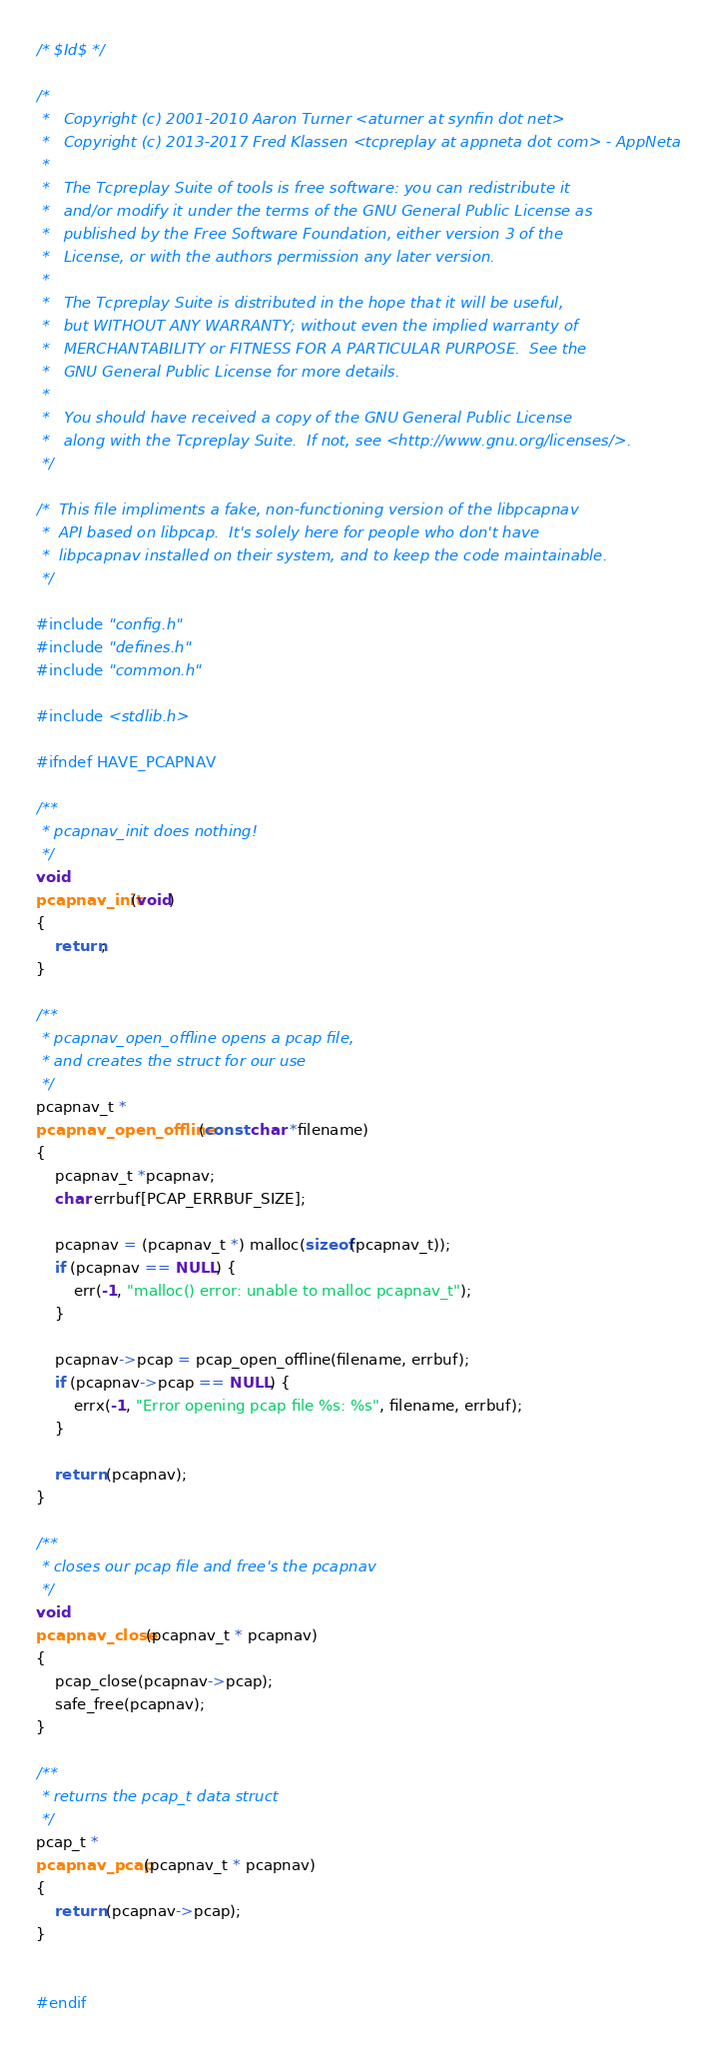<code> <loc_0><loc_0><loc_500><loc_500><_C_>/* $Id$ */

/*
 *   Copyright (c) 2001-2010 Aaron Turner <aturner at synfin dot net>
 *   Copyright (c) 2013-2017 Fred Klassen <tcpreplay at appneta dot com> - AppNeta
 *
 *   The Tcpreplay Suite of tools is free software: you can redistribute it 
 *   and/or modify it under the terms of the GNU General Public License as 
 *   published by the Free Software Foundation, either version 3 of the 
 *   License, or with the authors permission any later version.
 *
 *   The Tcpreplay Suite is distributed in the hope that it will be useful,
 *   but WITHOUT ANY WARRANTY; without even the implied warranty of
 *   MERCHANTABILITY or FITNESS FOR A PARTICULAR PURPOSE.  See the
 *   GNU General Public License for more details.
 *
 *   You should have received a copy of the GNU General Public License
 *   along with the Tcpreplay Suite.  If not, see <http://www.gnu.org/licenses/>.
 */

/*  This file impliments a fake, non-functioning version of the libpcapnav
 *  API based on libpcap.  It's solely here for people who don't have 
 *  libpcapnav installed on their system, and to keep the code maintainable.
 */

#include "config.h"
#include "defines.h"
#include "common.h"

#include <stdlib.h>

#ifndef HAVE_PCAPNAV

/**
 * pcapnav_init does nothing!  
 */
void
pcapnav_init(void)
{
    return;
}

/**
 * pcapnav_open_offline opens a pcap file, 
 * and creates the struct for our use  
 */
pcapnav_t *
pcapnav_open_offline(const char *filename)
{
    pcapnav_t *pcapnav;
    char errbuf[PCAP_ERRBUF_SIZE];

    pcapnav = (pcapnav_t *) malloc(sizeof(pcapnav_t));
    if (pcapnav == NULL) {
        err(-1, "malloc() error: unable to malloc pcapnav_t");
    }

    pcapnav->pcap = pcap_open_offline(filename, errbuf);
    if (pcapnav->pcap == NULL) {
        errx(-1, "Error opening pcap file %s: %s", filename, errbuf);
    }

    return (pcapnav);
}

/**
 * closes our pcap file and free's the pcapnav 
 */
void
pcapnav_close(pcapnav_t * pcapnav)
{
    pcap_close(pcapnav->pcap);
    safe_free(pcapnav);
}

/**
 * returns the pcap_t data struct 
 */
pcap_t *
pcapnav_pcap(pcapnav_t * pcapnav)
{
    return (pcapnav->pcap);
}


#endif
</code> 